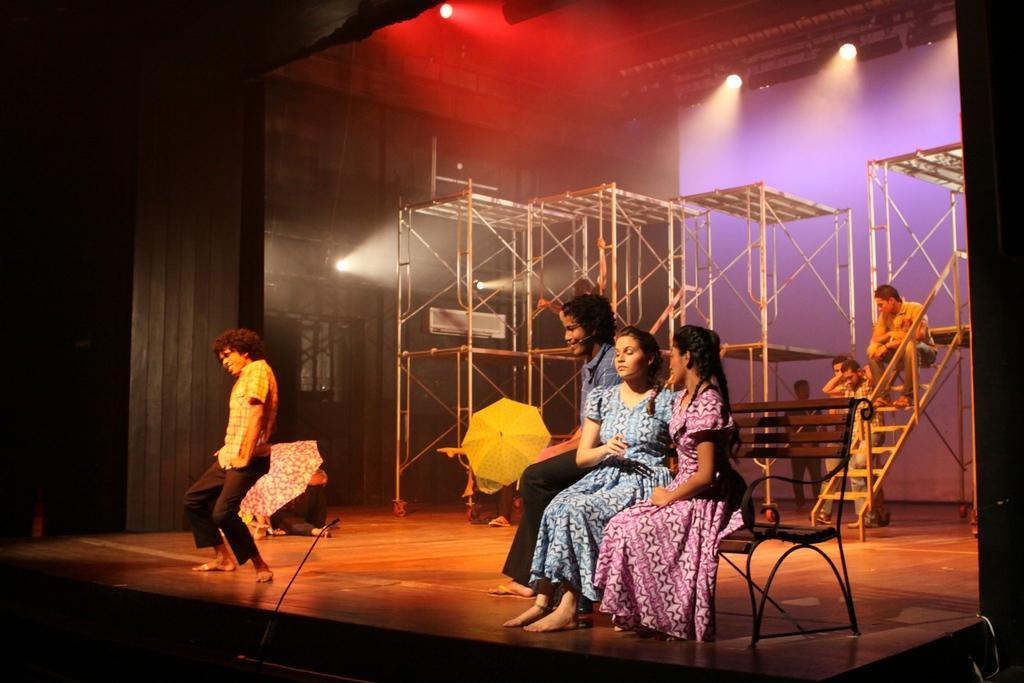Please provide a concise description of this image. In this image there are three persons sitting on the bench on the right side of this image and there is one person standing on the left side of this image. There are some iron objects as we can see in middle of this image. There is a wall in the background. There are some lights arranged on the top of this image. 